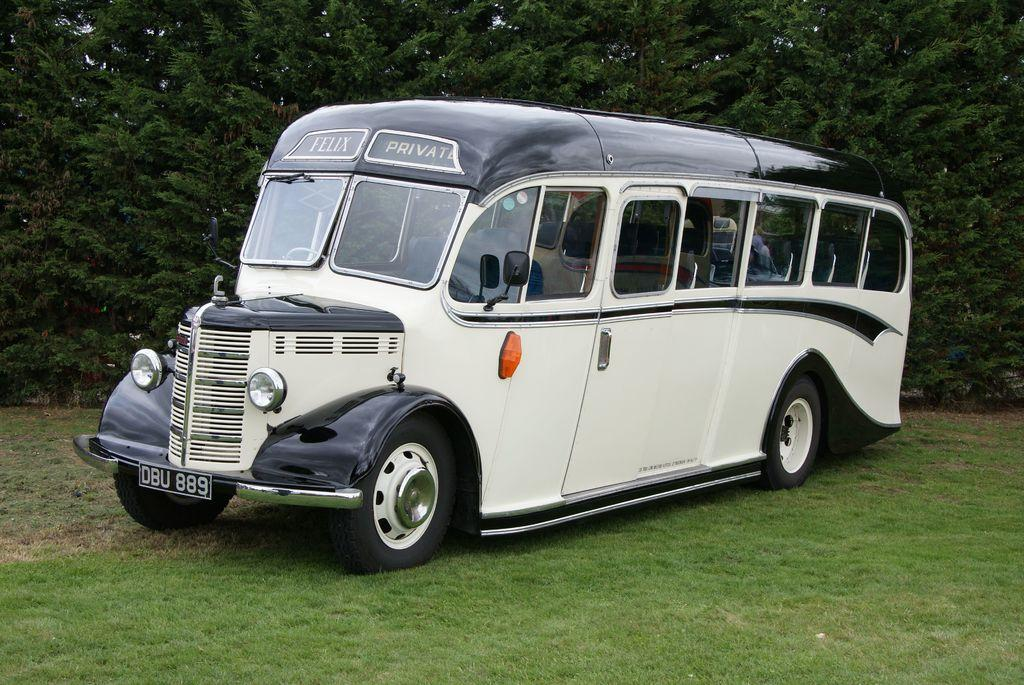<image>
Render a clear and concise summary of the photo. Oddly shaped bus that is apparently for private use only. 